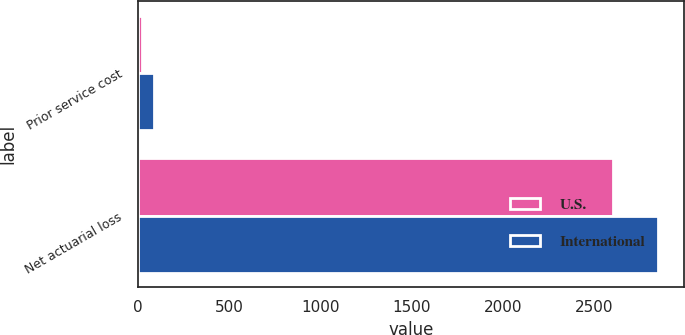Convert chart. <chart><loc_0><loc_0><loc_500><loc_500><stacked_bar_chart><ecel><fcel>Prior service cost<fcel>Net actuarial loss<nl><fcel>U.S.<fcel>23<fcel>2599<nl><fcel>International<fcel>90<fcel>2847<nl></chart> 